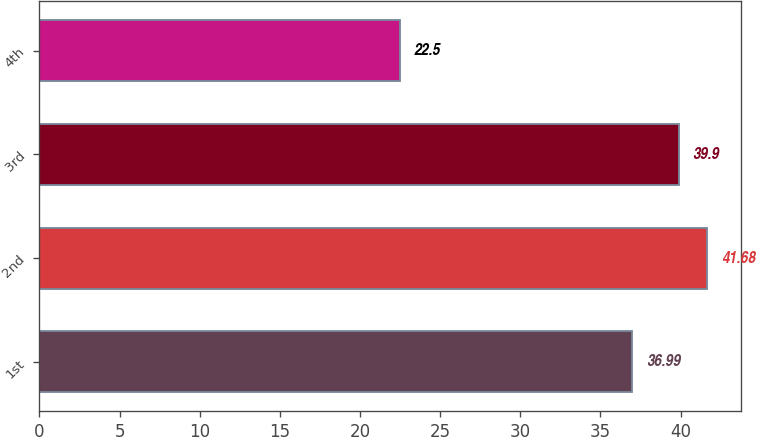Convert chart to OTSL. <chart><loc_0><loc_0><loc_500><loc_500><bar_chart><fcel>1st<fcel>2nd<fcel>3rd<fcel>4th<nl><fcel>36.99<fcel>41.68<fcel>39.9<fcel>22.5<nl></chart> 